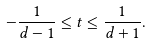Convert formula to latex. <formula><loc_0><loc_0><loc_500><loc_500>- \frac { 1 } { d - 1 } \leq t \leq \frac { 1 } { d + 1 } .</formula> 